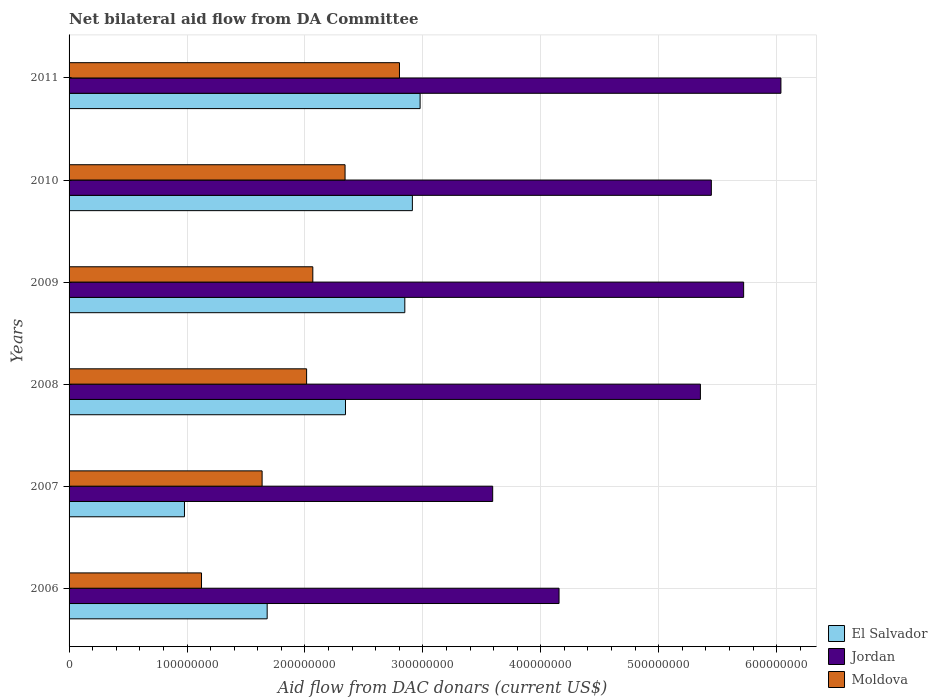How many different coloured bars are there?
Provide a short and direct response. 3. How many groups of bars are there?
Offer a terse response. 6. Are the number of bars per tick equal to the number of legend labels?
Give a very brief answer. Yes. Are the number of bars on each tick of the Y-axis equal?
Provide a succinct answer. Yes. How many bars are there on the 5th tick from the top?
Offer a terse response. 3. How many bars are there on the 4th tick from the bottom?
Ensure brevity in your answer.  3. What is the aid flow in in Jordan in 2009?
Provide a short and direct response. 5.72e+08. Across all years, what is the maximum aid flow in in Moldova?
Keep it short and to the point. 2.80e+08. Across all years, what is the minimum aid flow in in El Salvador?
Your answer should be compact. 9.79e+07. In which year was the aid flow in in El Salvador maximum?
Offer a terse response. 2011. What is the total aid flow in in El Salvador in the graph?
Make the answer very short. 1.37e+09. What is the difference between the aid flow in in Jordan in 2007 and that in 2008?
Make the answer very short. -1.76e+08. What is the difference between the aid flow in in El Salvador in 2009 and the aid flow in in Jordan in 2008?
Your answer should be very brief. -2.51e+08. What is the average aid flow in in Jordan per year?
Give a very brief answer. 5.05e+08. In the year 2007, what is the difference between the aid flow in in Moldova and aid flow in in Jordan?
Make the answer very short. -1.96e+08. What is the ratio of the aid flow in in Moldova in 2008 to that in 2010?
Provide a succinct answer. 0.86. Is the aid flow in in El Salvador in 2006 less than that in 2010?
Offer a very short reply. Yes. What is the difference between the highest and the second highest aid flow in in El Salvador?
Keep it short and to the point. 6.56e+06. What is the difference between the highest and the lowest aid flow in in Jordan?
Your answer should be very brief. 2.44e+08. What does the 1st bar from the top in 2010 represents?
Provide a short and direct response. Moldova. What does the 3rd bar from the bottom in 2007 represents?
Your answer should be compact. Moldova. Is it the case that in every year, the sum of the aid flow in in Jordan and aid flow in in El Salvador is greater than the aid flow in in Moldova?
Make the answer very short. Yes. How many bars are there?
Offer a terse response. 18. Are all the bars in the graph horizontal?
Ensure brevity in your answer.  Yes. What is the difference between two consecutive major ticks on the X-axis?
Give a very brief answer. 1.00e+08. Does the graph contain any zero values?
Your response must be concise. No. Where does the legend appear in the graph?
Give a very brief answer. Bottom right. How are the legend labels stacked?
Keep it short and to the point. Vertical. What is the title of the graph?
Give a very brief answer. Net bilateral aid flow from DA Committee. What is the label or title of the X-axis?
Provide a short and direct response. Aid flow from DAC donars (current US$). What is the label or title of the Y-axis?
Provide a short and direct response. Years. What is the Aid flow from DAC donars (current US$) in El Salvador in 2006?
Your answer should be compact. 1.68e+08. What is the Aid flow from DAC donars (current US$) in Jordan in 2006?
Keep it short and to the point. 4.16e+08. What is the Aid flow from DAC donars (current US$) of Moldova in 2006?
Your answer should be compact. 1.12e+08. What is the Aid flow from DAC donars (current US$) of El Salvador in 2007?
Make the answer very short. 9.79e+07. What is the Aid flow from DAC donars (current US$) of Jordan in 2007?
Make the answer very short. 3.59e+08. What is the Aid flow from DAC donars (current US$) in Moldova in 2007?
Your answer should be compact. 1.64e+08. What is the Aid flow from DAC donars (current US$) in El Salvador in 2008?
Provide a short and direct response. 2.34e+08. What is the Aid flow from DAC donars (current US$) of Jordan in 2008?
Your answer should be compact. 5.35e+08. What is the Aid flow from DAC donars (current US$) in Moldova in 2008?
Give a very brief answer. 2.01e+08. What is the Aid flow from DAC donars (current US$) in El Salvador in 2009?
Offer a terse response. 2.85e+08. What is the Aid flow from DAC donars (current US$) of Jordan in 2009?
Your answer should be very brief. 5.72e+08. What is the Aid flow from DAC donars (current US$) of Moldova in 2009?
Your response must be concise. 2.07e+08. What is the Aid flow from DAC donars (current US$) of El Salvador in 2010?
Your answer should be very brief. 2.91e+08. What is the Aid flow from DAC donars (current US$) of Jordan in 2010?
Ensure brevity in your answer.  5.45e+08. What is the Aid flow from DAC donars (current US$) of Moldova in 2010?
Ensure brevity in your answer.  2.34e+08. What is the Aid flow from DAC donars (current US$) in El Salvador in 2011?
Provide a short and direct response. 2.98e+08. What is the Aid flow from DAC donars (current US$) in Jordan in 2011?
Your answer should be compact. 6.04e+08. What is the Aid flow from DAC donars (current US$) of Moldova in 2011?
Keep it short and to the point. 2.80e+08. Across all years, what is the maximum Aid flow from DAC donars (current US$) in El Salvador?
Keep it short and to the point. 2.98e+08. Across all years, what is the maximum Aid flow from DAC donars (current US$) in Jordan?
Make the answer very short. 6.04e+08. Across all years, what is the maximum Aid flow from DAC donars (current US$) of Moldova?
Make the answer very short. 2.80e+08. Across all years, what is the minimum Aid flow from DAC donars (current US$) of El Salvador?
Keep it short and to the point. 9.79e+07. Across all years, what is the minimum Aid flow from DAC donars (current US$) of Jordan?
Your answer should be very brief. 3.59e+08. Across all years, what is the minimum Aid flow from DAC donars (current US$) in Moldova?
Provide a succinct answer. 1.12e+08. What is the total Aid flow from DAC donars (current US$) of El Salvador in the graph?
Your answer should be compact. 1.37e+09. What is the total Aid flow from DAC donars (current US$) in Jordan in the graph?
Your response must be concise. 3.03e+09. What is the total Aid flow from DAC donars (current US$) in Moldova in the graph?
Offer a terse response. 1.20e+09. What is the difference between the Aid flow from DAC donars (current US$) of El Salvador in 2006 and that in 2007?
Offer a terse response. 7.01e+07. What is the difference between the Aid flow from DAC donars (current US$) of Jordan in 2006 and that in 2007?
Offer a terse response. 5.63e+07. What is the difference between the Aid flow from DAC donars (current US$) of Moldova in 2006 and that in 2007?
Keep it short and to the point. -5.14e+07. What is the difference between the Aid flow from DAC donars (current US$) in El Salvador in 2006 and that in 2008?
Your response must be concise. -6.64e+07. What is the difference between the Aid flow from DAC donars (current US$) in Jordan in 2006 and that in 2008?
Your answer should be very brief. -1.20e+08. What is the difference between the Aid flow from DAC donars (current US$) of Moldova in 2006 and that in 2008?
Your answer should be compact. -8.91e+07. What is the difference between the Aid flow from DAC donars (current US$) of El Salvador in 2006 and that in 2009?
Provide a succinct answer. -1.17e+08. What is the difference between the Aid flow from DAC donars (current US$) in Jordan in 2006 and that in 2009?
Offer a very short reply. -1.57e+08. What is the difference between the Aid flow from DAC donars (current US$) in Moldova in 2006 and that in 2009?
Give a very brief answer. -9.44e+07. What is the difference between the Aid flow from DAC donars (current US$) of El Salvador in 2006 and that in 2010?
Keep it short and to the point. -1.23e+08. What is the difference between the Aid flow from DAC donars (current US$) of Jordan in 2006 and that in 2010?
Your answer should be very brief. -1.29e+08. What is the difference between the Aid flow from DAC donars (current US$) of Moldova in 2006 and that in 2010?
Your response must be concise. -1.22e+08. What is the difference between the Aid flow from DAC donars (current US$) in El Salvador in 2006 and that in 2011?
Ensure brevity in your answer.  -1.30e+08. What is the difference between the Aid flow from DAC donars (current US$) in Jordan in 2006 and that in 2011?
Ensure brevity in your answer.  -1.88e+08. What is the difference between the Aid flow from DAC donars (current US$) in Moldova in 2006 and that in 2011?
Keep it short and to the point. -1.68e+08. What is the difference between the Aid flow from DAC donars (current US$) in El Salvador in 2007 and that in 2008?
Your answer should be compact. -1.37e+08. What is the difference between the Aid flow from DAC donars (current US$) of Jordan in 2007 and that in 2008?
Give a very brief answer. -1.76e+08. What is the difference between the Aid flow from DAC donars (current US$) in Moldova in 2007 and that in 2008?
Keep it short and to the point. -3.77e+07. What is the difference between the Aid flow from DAC donars (current US$) of El Salvador in 2007 and that in 2009?
Give a very brief answer. -1.87e+08. What is the difference between the Aid flow from DAC donars (current US$) in Jordan in 2007 and that in 2009?
Provide a succinct answer. -2.13e+08. What is the difference between the Aid flow from DAC donars (current US$) of Moldova in 2007 and that in 2009?
Provide a succinct answer. -4.30e+07. What is the difference between the Aid flow from DAC donars (current US$) of El Salvador in 2007 and that in 2010?
Provide a succinct answer. -1.93e+08. What is the difference between the Aid flow from DAC donars (current US$) in Jordan in 2007 and that in 2010?
Ensure brevity in your answer.  -1.85e+08. What is the difference between the Aid flow from DAC donars (current US$) in Moldova in 2007 and that in 2010?
Give a very brief answer. -7.04e+07. What is the difference between the Aid flow from DAC donars (current US$) in El Salvador in 2007 and that in 2011?
Provide a succinct answer. -2.00e+08. What is the difference between the Aid flow from DAC donars (current US$) in Jordan in 2007 and that in 2011?
Offer a terse response. -2.44e+08. What is the difference between the Aid flow from DAC donars (current US$) in Moldova in 2007 and that in 2011?
Provide a succinct answer. -1.16e+08. What is the difference between the Aid flow from DAC donars (current US$) in El Salvador in 2008 and that in 2009?
Provide a succinct answer. -5.03e+07. What is the difference between the Aid flow from DAC donars (current US$) of Jordan in 2008 and that in 2009?
Your answer should be very brief. -3.67e+07. What is the difference between the Aid flow from DAC donars (current US$) in Moldova in 2008 and that in 2009?
Your answer should be compact. -5.26e+06. What is the difference between the Aid flow from DAC donars (current US$) of El Salvador in 2008 and that in 2010?
Make the answer very short. -5.67e+07. What is the difference between the Aid flow from DAC donars (current US$) of Jordan in 2008 and that in 2010?
Offer a very short reply. -9.28e+06. What is the difference between the Aid flow from DAC donars (current US$) of Moldova in 2008 and that in 2010?
Keep it short and to the point. -3.26e+07. What is the difference between the Aid flow from DAC donars (current US$) in El Salvador in 2008 and that in 2011?
Offer a terse response. -6.33e+07. What is the difference between the Aid flow from DAC donars (current US$) in Jordan in 2008 and that in 2011?
Your answer should be very brief. -6.83e+07. What is the difference between the Aid flow from DAC donars (current US$) of Moldova in 2008 and that in 2011?
Provide a succinct answer. -7.88e+07. What is the difference between the Aid flow from DAC donars (current US$) in El Salvador in 2009 and that in 2010?
Provide a succinct answer. -6.42e+06. What is the difference between the Aid flow from DAC donars (current US$) in Jordan in 2009 and that in 2010?
Your answer should be compact. 2.74e+07. What is the difference between the Aid flow from DAC donars (current US$) of Moldova in 2009 and that in 2010?
Offer a very short reply. -2.74e+07. What is the difference between the Aid flow from DAC donars (current US$) of El Salvador in 2009 and that in 2011?
Your response must be concise. -1.30e+07. What is the difference between the Aid flow from DAC donars (current US$) of Jordan in 2009 and that in 2011?
Your response must be concise. -3.16e+07. What is the difference between the Aid flow from DAC donars (current US$) in Moldova in 2009 and that in 2011?
Provide a succinct answer. -7.35e+07. What is the difference between the Aid flow from DAC donars (current US$) in El Salvador in 2010 and that in 2011?
Provide a short and direct response. -6.56e+06. What is the difference between the Aid flow from DAC donars (current US$) of Jordan in 2010 and that in 2011?
Provide a short and direct response. -5.90e+07. What is the difference between the Aid flow from DAC donars (current US$) of Moldova in 2010 and that in 2011?
Make the answer very short. -4.61e+07. What is the difference between the Aid flow from DAC donars (current US$) of El Salvador in 2006 and the Aid flow from DAC donars (current US$) of Jordan in 2007?
Your response must be concise. -1.91e+08. What is the difference between the Aid flow from DAC donars (current US$) in El Salvador in 2006 and the Aid flow from DAC donars (current US$) in Moldova in 2007?
Give a very brief answer. 4.29e+06. What is the difference between the Aid flow from DAC donars (current US$) of Jordan in 2006 and the Aid flow from DAC donars (current US$) of Moldova in 2007?
Provide a succinct answer. 2.52e+08. What is the difference between the Aid flow from DAC donars (current US$) in El Salvador in 2006 and the Aid flow from DAC donars (current US$) in Jordan in 2008?
Your response must be concise. -3.67e+08. What is the difference between the Aid flow from DAC donars (current US$) in El Salvador in 2006 and the Aid flow from DAC donars (current US$) in Moldova in 2008?
Provide a succinct answer. -3.34e+07. What is the difference between the Aid flow from DAC donars (current US$) of Jordan in 2006 and the Aid flow from DAC donars (current US$) of Moldova in 2008?
Offer a terse response. 2.14e+08. What is the difference between the Aid flow from DAC donars (current US$) of El Salvador in 2006 and the Aid flow from DAC donars (current US$) of Jordan in 2009?
Give a very brief answer. -4.04e+08. What is the difference between the Aid flow from DAC donars (current US$) in El Salvador in 2006 and the Aid flow from DAC donars (current US$) in Moldova in 2009?
Provide a short and direct response. -3.87e+07. What is the difference between the Aid flow from DAC donars (current US$) of Jordan in 2006 and the Aid flow from DAC donars (current US$) of Moldova in 2009?
Ensure brevity in your answer.  2.09e+08. What is the difference between the Aid flow from DAC donars (current US$) in El Salvador in 2006 and the Aid flow from DAC donars (current US$) in Jordan in 2010?
Offer a terse response. -3.77e+08. What is the difference between the Aid flow from DAC donars (current US$) in El Salvador in 2006 and the Aid flow from DAC donars (current US$) in Moldova in 2010?
Your answer should be compact. -6.61e+07. What is the difference between the Aid flow from DAC donars (current US$) in Jordan in 2006 and the Aid flow from DAC donars (current US$) in Moldova in 2010?
Keep it short and to the point. 1.81e+08. What is the difference between the Aid flow from DAC donars (current US$) in El Salvador in 2006 and the Aid flow from DAC donars (current US$) in Jordan in 2011?
Your answer should be very brief. -4.36e+08. What is the difference between the Aid flow from DAC donars (current US$) of El Salvador in 2006 and the Aid flow from DAC donars (current US$) of Moldova in 2011?
Keep it short and to the point. -1.12e+08. What is the difference between the Aid flow from DAC donars (current US$) of Jordan in 2006 and the Aid flow from DAC donars (current US$) of Moldova in 2011?
Give a very brief answer. 1.35e+08. What is the difference between the Aid flow from DAC donars (current US$) in El Salvador in 2007 and the Aid flow from DAC donars (current US$) in Jordan in 2008?
Give a very brief answer. -4.38e+08. What is the difference between the Aid flow from DAC donars (current US$) in El Salvador in 2007 and the Aid flow from DAC donars (current US$) in Moldova in 2008?
Offer a very short reply. -1.04e+08. What is the difference between the Aid flow from DAC donars (current US$) of Jordan in 2007 and the Aid flow from DAC donars (current US$) of Moldova in 2008?
Provide a succinct answer. 1.58e+08. What is the difference between the Aid flow from DAC donars (current US$) of El Salvador in 2007 and the Aid flow from DAC donars (current US$) of Jordan in 2009?
Your answer should be very brief. -4.74e+08. What is the difference between the Aid flow from DAC donars (current US$) in El Salvador in 2007 and the Aid flow from DAC donars (current US$) in Moldova in 2009?
Your answer should be compact. -1.09e+08. What is the difference between the Aid flow from DAC donars (current US$) in Jordan in 2007 and the Aid flow from DAC donars (current US$) in Moldova in 2009?
Your response must be concise. 1.53e+08. What is the difference between the Aid flow from DAC donars (current US$) in El Salvador in 2007 and the Aid flow from DAC donars (current US$) in Jordan in 2010?
Your response must be concise. -4.47e+08. What is the difference between the Aid flow from DAC donars (current US$) in El Salvador in 2007 and the Aid flow from DAC donars (current US$) in Moldova in 2010?
Your answer should be very brief. -1.36e+08. What is the difference between the Aid flow from DAC donars (current US$) in Jordan in 2007 and the Aid flow from DAC donars (current US$) in Moldova in 2010?
Your answer should be very brief. 1.25e+08. What is the difference between the Aid flow from DAC donars (current US$) in El Salvador in 2007 and the Aid flow from DAC donars (current US$) in Jordan in 2011?
Keep it short and to the point. -5.06e+08. What is the difference between the Aid flow from DAC donars (current US$) of El Salvador in 2007 and the Aid flow from DAC donars (current US$) of Moldova in 2011?
Make the answer very short. -1.82e+08. What is the difference between the Aid flow from DAC donars (current US$) in Jordan in 2007 and the Aid flow from DAC donars (current US$) in Moldova in 2011?
Your response must be concise. 7.90e+07. What is the difference between the Aid flow from DAC donars (current US$) in El Salvador in 2008 and the Aid flow from DAC donars (current US$) in Jordan in 2009?
Provide a succinct answer. -3.38e+08. What is the difference between the Aid flow from DAC donars (current US$) of El Salvador in 2008 and the Aid flow from DAC donars (current US$) of Moldova in 2009?
Offer a terse response. 2.77e+07. What is the difference between the Aid flow from DAC donars (current US$) of Jordan in 2008 and the Aid flow from DAC donars (current US$) of Moldova in 2009?
Make the answer very short. 3.29e+08. What is the difference between the Aid flow from DAC donars (current US$) of El Salvador in 2008 and the Aid flow from DAC donars (current US$) of Jordan in 2010?
Offer a terse response. -3.10e+08. What is the difference between the Aid flow from DAC donars (current US$) of El Salvador in 2008 and the Aid flow from DAC donars (current US$) of Moldova in 2010?
Keep it short and to the point. 3.50e+05. What is the difference between the Aid flow from DAC donars (current US$) of Jordan in 2008 and the Aid flow from DAC donars (current US$) of Moldova in 2010?
Your response must be concise. 3.01e+08. What is the difference between the Aid flow from DAC donars (current US$) in El Salvador in 2008 and the Aid flow from DAC donars (current US$) in Jordan in 2011?
Provide a succinct answer. -3.69e+08. What is the difference between the Aid flow from DAC donars (current US$) of El Salvador in 2008 and the Aid flow from DAC donars (current US$) of Moldova in 2011?
Your answer should be compact. -4.58e+07. What is the difference between the Aid flow from DAC donars (current US$) of Jordan in 2008 and the Aid flow from DAC donars (current US$) of Moldova in 2011?
Offer a very short reply. 2.55e+08. What is the difference between the Aid flow from DAC donars (current US$) in El Salvador in 2009 and the Aid flow from DAC donars (current US$) in Jordan in 2010?
Make the answer very short. -2.60e+08. What is the difference between the Aid flow from DAC donars (current US$) in El Salvador in 2009 and the Aid flow from DAC donars (current US$) in Moldova in 2010?
Offer a very short reply. 5.07e+07. What is the difference between the Aid flow from DAC donars (current US$) of Jordan in 2009 and the Aid flow from DAC donars (current US$) of Moldova in 2010?
Your response must be concise. 3.38e+08. What is the difference between the Aid flow from DAC donars (current US$) of El Salvador in 2009 and the Aid flow from DAC donars (current US$) of Jordan in 2011?
Your response must be concise. -3.19e+08. What is the difference between the Aid flow from DAC donars (current US$) in El Salvador in 2009 and the Aid flow from DAC donars (current US$) in Moldova in 2011?
Provide a short and direct response. 4.52e+06. What is the difference between the Aid flow from DAC donars (current US$) in Jordan in 2009 and the Aid flow from DAC donars (current US$) in Moldova in 2011?
Offer a very short reply. 2.92e+08. What is the difference between the Aid flow from DAC donars (current US$) of El Salvador in 2010 and the Aid flow from DAC donars (current US$) of Jordan in 2011?
Keep it short and to the point. -3.13e+08. What is the difference between the Aid flow from DAC donars (current US$) in El Salvador in 2010 and the Aid flow from DAC donars (current US$) in Moldova in 2011?
Your answer should be very brief. 1.09e+07. What is the difference between the Aid flow from DAC donars (current US$) in Jordan in 2010 and the Aid flow from DAC donars (current US$) in Moldova in 2011?
Your answer should be compact. 2.64e+08. What is the average Aid flow from DAC donars (current US$) in El Salvador per year?
Your response must be concise. 2.29e+08. What is the average Aid flow from DAC donars (current US$) of Jordan per year?
Keep it short and to the point. 5.05e+08. What is the average Aid flow from DAC donars (current US$) in Moldova per year?
Offer a very short reply. 2.00e+08. In the year 2006, what is the difference between the Aid flow from DAC donars (current US$) in El Salvador and Aid flow from DAC donars (current US$) in Jordan?
Your response must be concise. -2.48e+08. In the year 2006, what is the difference between the Aid flow from DAC donars (current US$) in El Salvador and Aid flow from DAC donars (current US$) in Moldova?
Keep it short and to the point. 5.57e+07. In the year 2006, what is the difference between the Aid flow from DAC donars (current US$) in Jordan and Aid flow from DAC donars (current US$) in Moldova?
Your answer should be very brief. 3.03e+08. In the year 2007, what is the difference between the Aid flow from DAC donars (current US$) of El Salvador and Aid flow from DAC donars (current US$) of Jordan?
Ensure brevity in your answer.  -2.61e+08. In the year 2007, what is the difference between the Aid flow from DAC donars (current US$) in El Salvador and Aid flow from DAC donars (current US$) in Moldova?
Your answer should be very brief. -6.58e+07. In the year 2007, what is the difference between the Aid flow from DAC donars (current US$) in Jordan and Aid flow from DAC donars (current US$) in Moldova?
Offer a terse response. 1.96e+08. In the year 2008, what is the difference between the Aid flow from DAC donars (current US$) of El Salvador and Aid flow from DAC donars (current US$) of Jordan?
Provide a short and direct response. -3.01e+08. In the year 2008, what is the difference between the Aid flow from DAC donars (current US$) in El Salvador and Aid flow from DAC donars (current US$) in Moldova?
Ensure brevity in your answer.  3.30e+07. In the year 2008, what is the difference between the Aid flow from DAC donars (current US$) in Jordan and Aid flow from DAC donars (current US$) in Moldova?
Make the answer very short. 3.34e+08. In the year 2009, what is the difference between the Aid flow from DAC donars (current US$) in El Salvador and Aid flow from DAC donars (current US$) in Jordan?
Your answer should be very brief. -2.87e+08. In the year 2009, what is the difference between the Aid flow from DAC donars (current US$) of El Salvador and Aid flow from DAC donars (current US$) of Moldova?
Your answer should be very brief. 7.80e+07. In the year 2009, what is the difference between the Aid flow from DAC donars (current US$) of Jordan and Aid flow from DAC donars (current US$) of Moldova?
Keep it short and to the point. 3.65e+08. In the year 2010, what is the difference between the Aid flow from DAC donars (current US$) in El Salvador and Aid flow from DAC donars (current US$) in Jordan?
Make the answer very short. -2.54e+08. In the year 2010, what is the difference between the Aid flow from DAC donars (current US$) of El Salvador and Aid flow from DAC donars (current US$) of Moldova?
Offer a very short reply. 5.71e+07. In the year 2010, what is the difference between the Aid flow from DAC donars (current US$) of Jordan and Aid flow from DAC donars (current US$) of Moldova?
Keep it short and to the point. 3.11e+08. In the year 2011, what is the difference between the Aid flow from DAC donars (current US$) of El Salvador and Aid flow from DAC donars (current US$) of Jordan?
Provide a succinct answer. -3.06e+08. In the year 2011, what is the difference between the Aid flow from DAC donars (current US$) of El Salvador and Aid flow from DAC donars (current US$) of Moldova?
Keep it short and to the point. 1.75e+07. In the year 2011, what is the difference between the Aid flow from DAC donars (current US$) of Jordan and Aid flow from DAC donars (current US$) of Moldova?
Your answer should be very brief. 3.23e+08. What is the ratio of the Aid flow from DAC donars (current US$) in El Salvador in 2006 to that in 2007?
Ensure brevity in your answer.  1.72. What is the ratio of the Aid flow from DAC donars (current US$) in Jordan in 2006 to that in 2007?
Your answer should be compact. 1.16. What is the ratio of the Aid flow from DAC donars (current US$) of Moldova in 2006 to that in 2007?
Give a very brief answer. 0.69. What is the ratio of the Aid flow from DAC donars (current US$) of El Salvador in 2006 to that in 2008?
Offer a very short reply. 0.72. What is the ratio of the Aid flow from DAC donars (current US$) of Jordan in 2006 to that in 2008?
Your response must be concise. 0.78. What is the ratio of the Aid flow from DAC donars (current US$) in Moldova in 2006 to that in 2008?
Your answer should be compact. 0.56. What is the ratio of the Aid flow from DAC donars (current US$) of El Salvador in 2006 to that in 2009?
Make the answer very short. 0.59. What is the ratio of the Aid flow from DAC donars (current US$) in Jordan in 2006 to that in 2009?
Your response must be concise. 0.73. What is the ratio of the Aid flow from DAC donars (current US$) in Moldova in 2006 to that in 2009?
Your answer should be compact. 0.54. What is the ratio of the Aid flow from DAC donars (current US$) of El Salvador in 2006 to that in 2010?
Offer a very short reply. 0.58. What is the ratio of the Aid flow from DAC donars (current US$) in Jordan in 2006 to that in 2010?
Your answer should be very brief. 0.76. What is the ratio of the Aid flow from DAC donars (current US$) in Moldova in 2006 to that in 2010?
Your answer should be compact. 0.48. What is the ratio of the Aid flow from DAC donars (current US$) in El Salvador in 2006 to that in 2011?
Your answer should be compact. 0.56. What is the ratio of the Aid flow from DAC donars (current US$) of Jordan in 2006 to that in 2011?
Ensure brevity in your answer.  0.69. What is the ratio of the Aid flow from DAC donars (current US$) of Moldova in 2006 to that in 2011?
Offer a very short reply. 0.4. What is the ratio of the Aid flow from DAC donars (current US$) of El Salvador in 2007 to that in 2008?
Offer a terse response. 0.42. What is the ratio of the Aid flow from DAC donars (current US$) in Jordan in 2007 to that in 2008?
Keep it short and to the point. 0.67. What is the ratio of the Aid flow from DAC donars (current US$) of Moldova in 2007 to that in 2008?
Make the answer very short. 0.81. What is the ratio of the Aid flow from DAC donars (current US$) of El Salvador in 2007 to that in 2009?
Ensure brevity in your answer.  0.34. What is the ratio of the Aid flow from DAC donars (current US$) of Jordan in 2007 to that in 2009?
Offer a terse response. 0.63. What is the ratio of the Aid flow from DAC donars (current US$) in Moldova in 2007 to that in 2009?
Provide a succinct answer. 0.79. What is the ratio of the Aid flow from DAC donars (current US$) of El Salvador in 2007 to that in 2010?
Provide a short and direct response. 0.34. What is the ratio of the Aid flow from DAC donars (current US$) of Jordan in 2007 to that in 2010?
Provide a short and direct response. 0.66. What is the ratio of the Aid flow from DAC donars (current US$) in Moldova in 2007 to that in 2010?
Ensure brevity in your answer.  0.7. What is the ratio of the Aid flow from DAC donars (current US$) in El Salvador in 2007 to that in 2011?
Offer a terse response. 0.33. What is the ratio of the Aid flow from DAC donars (current US$) of Jordan in 2007 to that in 2011?
Offer a terse response. 0.6. What is the ratio of the Aid flow from DAC donars (current US$) of Moldova in 2007 to that in 2011?
Keep it short and to the point. 0.58. What is the ratio of the Aid flow from DAC donars (current US$) of El Salvador in 2008 to that in 2009?
Ensure brevity in your answer.  0.82. What is the ratio of the Aid flow from DAC donars (current US$) in Jordan in 2008 to that in 2009?
Offer a terse response. 0.94. What is the ratio of the Aid flow from DAC donars (current US$) in Moldova in 2008 to that in 2009?
Your answer should be compact. 0.97. What is the ratio of the Aid flow from DAC donars (current US$) in El Salvador in 2008 to that in 2010?
Ensure brevity in your answer.  0.81. What is the ratio of the Aid flow from DAC donars (current US$) in Jordan in 2008 to that in 2010?
Your answer should be very brief. 0.98. What is the ratio of the Aid flow from DAC donars (current US$) in Moldova in 2008 to that in 2010?
Your answer should be very brief. 0.86. What is the ratio of the Aid flow from DAC donars (current US$) in El Salvador in 2008 to that in 2011?
Give a very brief answer. 0.79. What is the ratio of the Aid flow from DAC donars (current US$) in Jordan in 2008 to that in 2011?
Your answer should be compact. 0.89. What is the ratio of the Aid flow from DAC donars (current US$) in Moldova in 2008 to that in 2011?
Your response must be concise. 0.72. What is the ratio of the Aid flow from DAC donars (current US$) in El Salvador in 2009 to that in 2010?
Give a very brief answer. 0.98. What is the ratio of the Aid flow from DAC donars (current US$) of Jordan in 2009 to that in 2010?
Offer a terse response. 1.05. What is the ratio of the Aid flow from DAC donars (current US$) in Moldova in 2009 to that in 2010?
Your answer should be compact. 0.88. What is the ratio of the Aid flow from DAC donars (current US$) of El Salvador in 2009 to that in 2011?
Offer a very short reply. 0.96. What is the ratio of the Aid flow from DAC donars (current US$) of Jordan in 2009 to that in 2011?
Offer a very short reply. 0.95. What is the ratio of the Aid flow from DAC donars (current US$) in Moldova in 2009 to that in 2011?
Give a very brief answer. 0.74. What is the ratio of the Aid flow from DAC donars (current US$) in El Salvador in 2010 to that in 2011?
Your answer should be compact. 0.98. What is the ratio of the Aid flow from DAC donars (current US$) of Jordan in 2010 to that in 2011?
Offer a terse response. 0.9. What is the ratio of the Aid flow from DAC donars (current US$) in Moldova in 2010 to that in 2011?
Your answer should be compact. 0.84. What is the difference between the highest and the second highest Aid flow from DAC donars (current US$) in El Salvador?
Offer a very short reply. 6.56e+06. What is the difference between the highest and the second highest Aid flow from DAC donars (current US$) of Jordan?
Offer a terse response. 3.16e+07. What is the difference between the highest and the second highest Aid flow from DAC donars (current US$) of Moldova?
Give a very brief answer. 4.61e+07. What is the difference between the highest and the lowest Aid flow from DAC donars (current US$) of El Salvador?
Offer a terse response. 2.00e+08. What is the difference between the highest and the lowest Aid flow from DAC donars (current US$) in Jordan?
Offer a terse response. 2.44e+08. What is the difference between the highest and the lowest Aid flow from DAC donars (current US$) of Moldova?
Provide a short and direct response. 1.68e+08. 